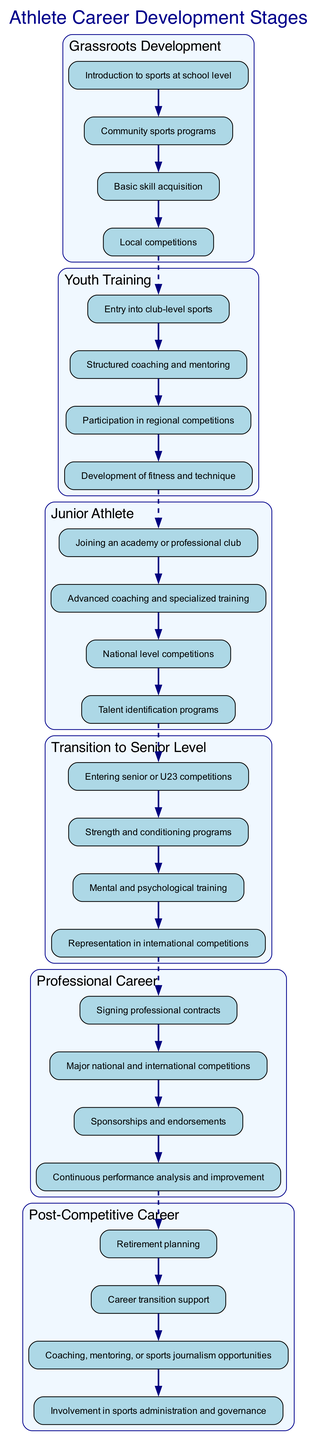What is the first stage of an athlete's career development? The diagram lists stages of career development starting from "Grassroots Development". This is observed at the top of the diagram.
Answer: Grassroots Development How many elements are in the "Junior Athlete" stage? In the "Junior Athlete" block, there are four listed elements. I counted these elements directly under the "Junior Athlete" label in the diagram.
Answer: 4 What connects "Youth Training" to "Junior Athlete"? The connection between "Youth Training" and "Junior Athlete" is represented by a dashed edge in the diagram. This indicates a flow from one stage to the next, showing progression.
Answer: Dashed edge Which stage includes "Mental and psychological training"? "Mental and psychological training" is listed under the "Transition to Senior Level" stage. Looking at the elements in that block confirms this.
Answer: Transition to Senior Level What is the last element listed in the "Post-Competitive Career" stage? In the "Post-Competitive Career" block, the last element mentioned is "Involvement in sports administration and governance". I reviewed the list from bottom to top to identify the last element.
Answer: Involvement in sports administration and governance How many total stages are represented in the diagram? By counting the numbered blocks in the diagram, I found that there are a total of six distinct stages outlined.
Answer: 6 What type of competitions are included in “Professional Career”? The "Professional Career" stage mentions "Major national and international competitions" among its elements, indicating the level at which professional athletes compete.
Answer: Major national and international competitions What is the relationship between "Grassroots Development" and "Youth Training"? The relationship is sequential; "Grassroots Development" feeds into "Youth Training", shown through the connected dashed edge that signifies progression into the next stage.
Answer: Sequential progression Which stage involves "Sponsorships and endorsements"? "Sponsorships and endorsements" is specified in the "Professional Career" stage, as seen in the elements listed under that block.
Answer: Professional Career 